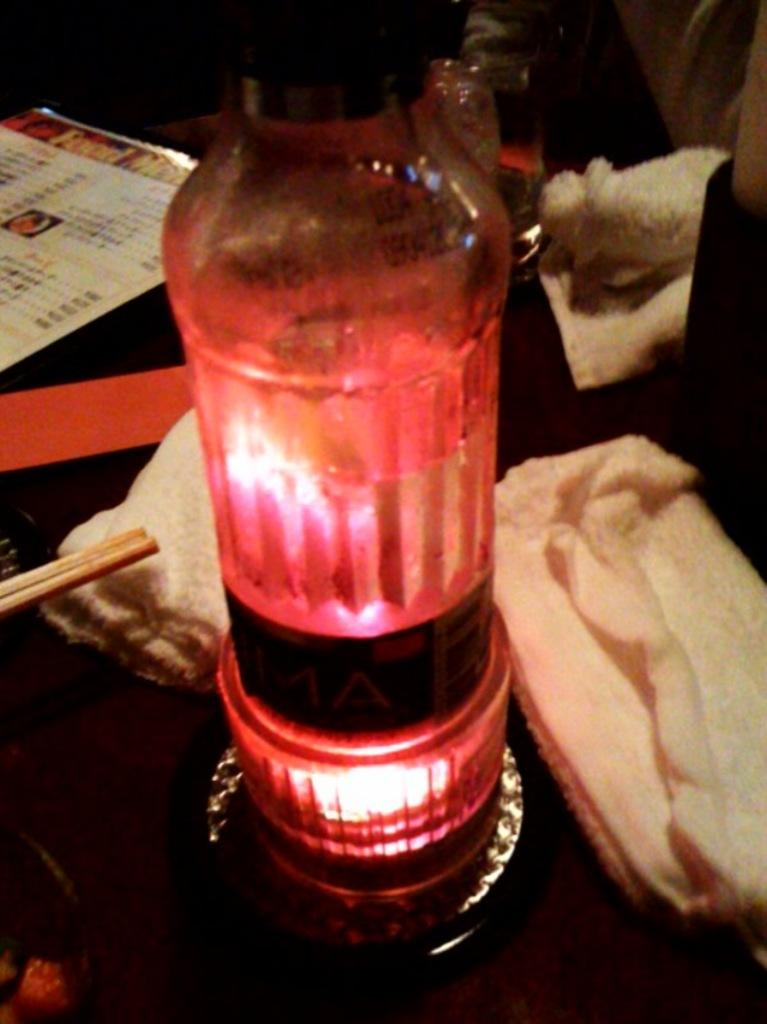What type of furniture is in the image? There is a table in the image. What items can be seen on the table? Napkins, chopsticks, bowls, a menu card, a glass, and a lamp are visible on the table. What might be used for cleaning or wiping in the image? Napkins are present in the image for cleaning or wiping. What is the person towards the right side of the image doing? The facts provided do not specify what the person is doing. What type of bone is visible on the table in the image? There is no bone present on the table in the image. What type of picture is hanging on the wall behind the person in the image? The facts provided do not mention any pictures or walls in the image. 